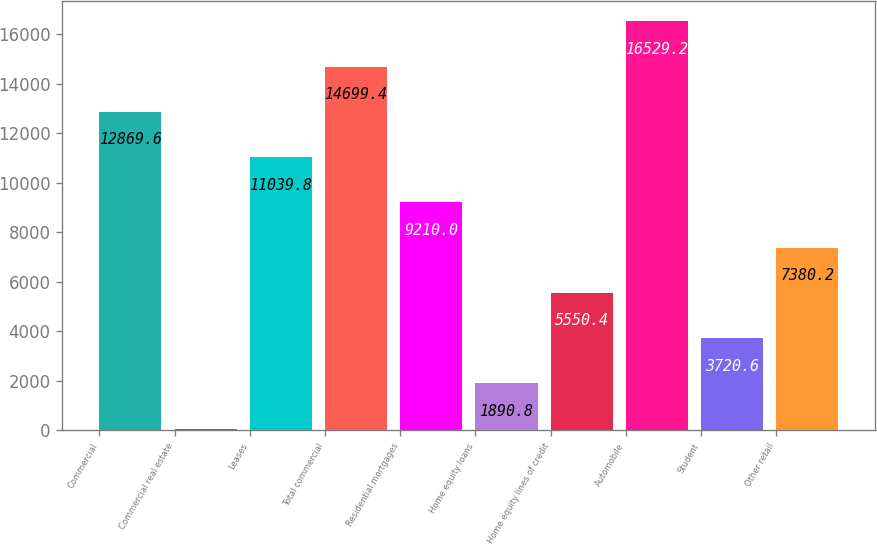Convert chart. <chart><loc_0><loc_0><loc_500><loc_500><bar_chart><fcel>Commercial<fcel>Commercial real estate<fcel>Leases<fcel>Total commercial<fcel>Residential mortgages<fcel>Home equity loans<fcel>Home equity lines of credit<fcel>Automobile<fcel>Student<fcel>Other retail<nl><fcel>12869.6<fcel>61<fcel>11039.8<fcel>14699.4<fcel>9210<fcel>1890.8<fcel>5550.4<fcel>16529.2<fcel>3720.6<fcel>7380.2<nl></chart> 